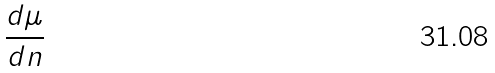Convert formula to latex. <formula><loc_0><loc_0><loc_500><loc_500>\frac { d \mu } { d n }</formula> 